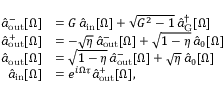Convert formula to latex. <formula><loc_0><loc_0><loc_500><loc_500>\begin{array} { r l } { \hat { a } _ { o u t } ^ { - } [ \Omega ] } & { = G \, \hat { a } _ { i n } [ \Omega ] + \sqrt { G ^ { 2 } - 1 } \, \hat { a } _ { G } ^ { \dagger } [ \Omega ] } \\ { \hat { a } _ { o u t } ^ { + } [ \Omega ] } & { = - \sqrt { \eta } \, \hat { a } _ { o u t } ^ { - } [ \Omega ] + \sqrt { 1 - \eta } \, \hat { a } _ { 0 } [ \Omega ] } \\ { \hat { a } _ { o u t } [ \Omega ] } & { = \sqrt { 1 - \eta } \, \hat { a } _ { o u t } ^ { - } [ \Omega ] + \sqrt { \eta } \, \hat { a } _ { 0 } [ \Omega ] } \\ { \hat { a } _ { i n } [ \Omega ] } & { = e ^ { i \Omega \tau } \hat { a } _ { o u t } ^ { + } [ \Omega ] , } \end{array}</formula> 